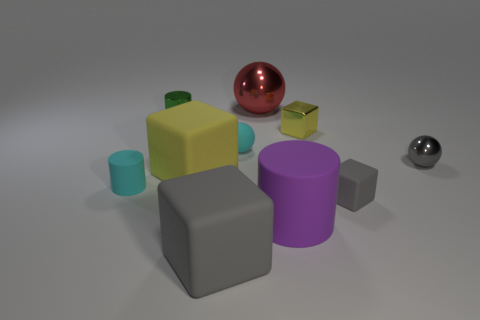Are there any large gray cubes in front of the gray sphere?
Make the answer very short. Yes. The big shiny sphere is what color?
Your response must be concise. Red. There is a big cylinder; does it have the same color as the shiny object behind the green cylinder?
Your response must be concise. No. Is there a purple matte thing that has the same size as the purple rubber cylinder?
Ensure brevity in your answer.  No. There is a shiny object that is the same color as the small rubber cube; what is its size?
Make the answer very short. Small. What is the material of the yellow block to the left of the large red metal object?
Your answer should be compact. Rubber. Is the number of tiny cyan spheres behind the big red shiny sphere the same as the number of purple things that are behind the small metallic ball?
Ensure brevity in your answer.  Yes. Is the size of the yellow block to the left of the big purple rubber cylinder the same as the metallic object that is in front of the small cyan rubber ball?
Your response must be concise. No. What number of cylinders have the same color as the small matte sphere?
Provide a succinct answer. 1. There is a small thing that is the same color as the matte ball; what is it made of?
Your answer should be compact. Rubber. 